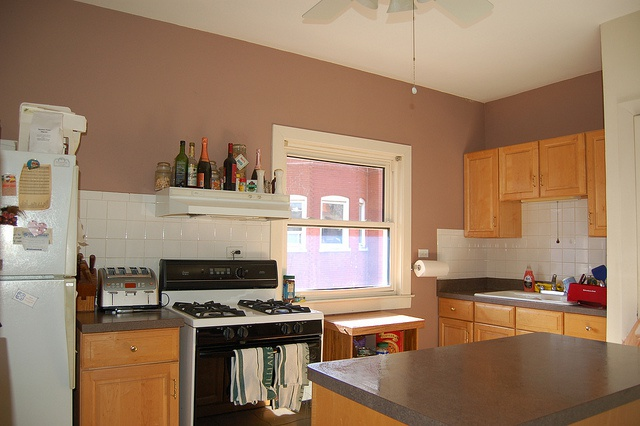Describe the objects in this image and their specific colors. I can see dining table in maroon, gray, and red tones, oven in maroon, black, darkgray, gray, and tan tones, refrigerator in maroon, darkgray, tan, lightgray, and gray tones, toaster in maroon, gray, darkgray, and black tones, and sink in maroon, darkgray, lightgray, tan, and gray tones in this image. 